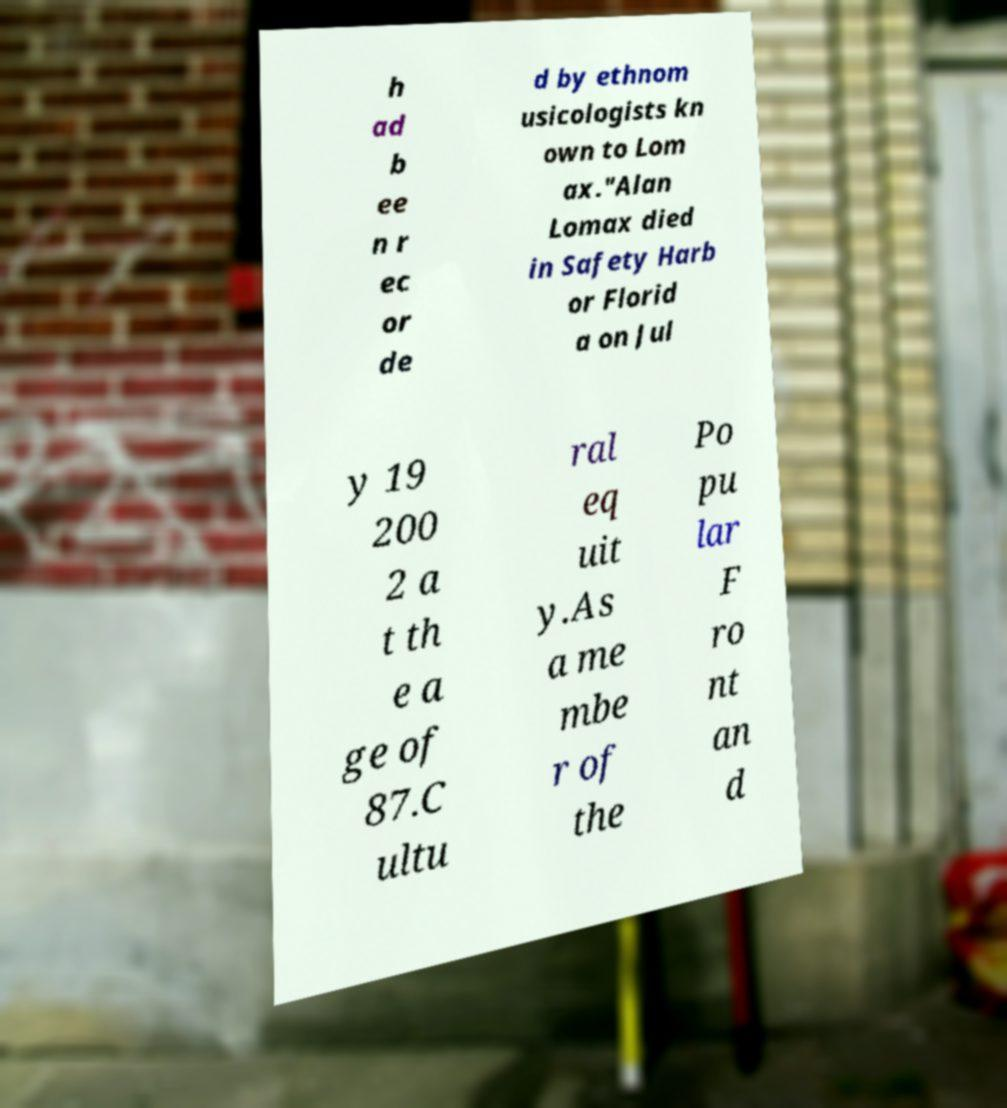Could you assist in decoding the text presented in this image and type it out clearly? h ad b ee n r ec or de d by ethnom usicologists kn own to Lom ax."Alan Lomax died in Safety Harb or Florid a on Jul y 19 200 2 a t th e a ge of 87.C ultu ral eq uit y.As a me mbe r of the Po pu lar F ro nt an d 